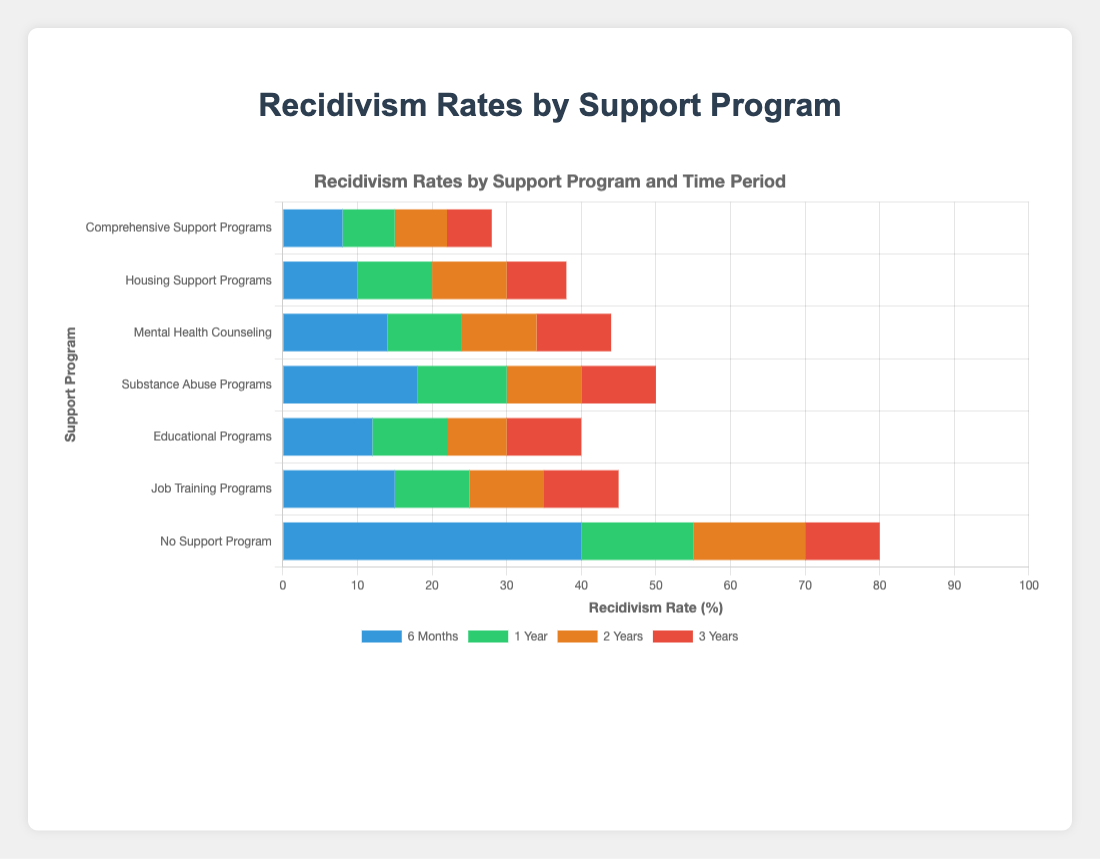What's the difference in recidivism rates after 6 months between those with no support program and those in comprehensive support programs? Look at the recidivism rates for the 'No Support Program' and 'Comprehensive Support Programs' at the 6-month mark. The rates are 40.0% and 8.0%, respectively. The difference is 40.0% - 8.0%.
Answer: 32.0% Which support program has the highest recidivism rate after 3 years? Examine the recidivism rates for all the support programs at the 3-year mark. The highest rate is for 'No Support Program', which is 80.0%.
Answer: No Support Program How does the recidivism rate after 1 year in educational programs compare to that in job training programs? Check the recidivism rates for 'Educational Programs' and 'Job Training Programs' at the 1-year mark, which are 22.0% and 25.0%, respectively. 'Educational Programs' has a lower rate.
Answer: Educational Programs is lower by 3.0% What's the total recidivism rate after 6 months for those enrolled in job training, educational, and substance abuse programs combined? Add the recidivism rates at the 6-month mark for 'Job Training Programs', 'Educational Programs', and 'Substance Abuse Programs': 15.0% + 12.0% + 18.0%.
Answer: 45.0% What is the average recidivism rate after 1 year for mental health counseling, housing support programs, and comprehensive support programs? Sum the recidivism rates for 'Mental Health Counseling' (24.0%), 'Housing Support Programs' (20.0%), and 'Comprehensive Support Programs' (15.0%), then divide by the number of programs (3). The total is 24.0% + 20.0% + 15.0% = 59.0%, and the average is 59.0% / 3.
Answer: 19.67% Which bar is the shortest in height for the 6-month recidivism rates? Visually assess the bar heights at the 6-month mark. The shortest bar corresponds to 'Comprehensive Support Programs' with a rate of 8.0%.
Answer: Comprehensive Support Programs What is the difference between the 3-year recidivism rates for those in housing support programs and those in substance abuse programs? Check the recidivism rates for 'Housing Support Programs' and 'Substance Abuse Programs' at the 3-year mark, which are 38.0% and 50.0%, respectively. The difference is 50.0% - 38.0%.
Answer: 12.0% What is the sum of the recidivism rates for the 'No Support Program' group across all time periods? Add the recidivism rates for 'No Support Program' at 6 months (40.0%), 1 year (55.0%), 2 years (70.0%), and 3 years (80.0%). The total is 40.0% + 55.0% + 70.0% + 80.0%.
Answer: 245.0% Compare the 2-year recidivism rates between job training programs and educational programs. Which is lower and by how much? Look at the recidivism rates at the 2-year mark for 'Job Training Programs' (35.0%) and 'Educational Programs' (30.0%). 'Educational Programs' is lower by 35.0% - 30.0%.
Answer: Educational Programs is lower by 5.0% Which support program sees the greatest increase in recidivism rates from 6 months to 3 years? Calculate the increase in recidivism rates from 6 months to 3 years for each program. 'No Support Program' has the largest increase: 80.0% - 40.0%.
Answer: No Support Program 